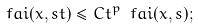<formula> <loc_0><loc_0><loc_500><loc_500>\ f a i ( x , s t ) \leq C t ^ { p } \ f a i ( x , s ) ;</formula> 